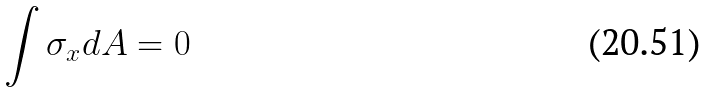Convert formula to latex. <formula><loc_0><loc_0><loc_500><loc_500>\int \sigma _ { x } d A = 0</formula> 